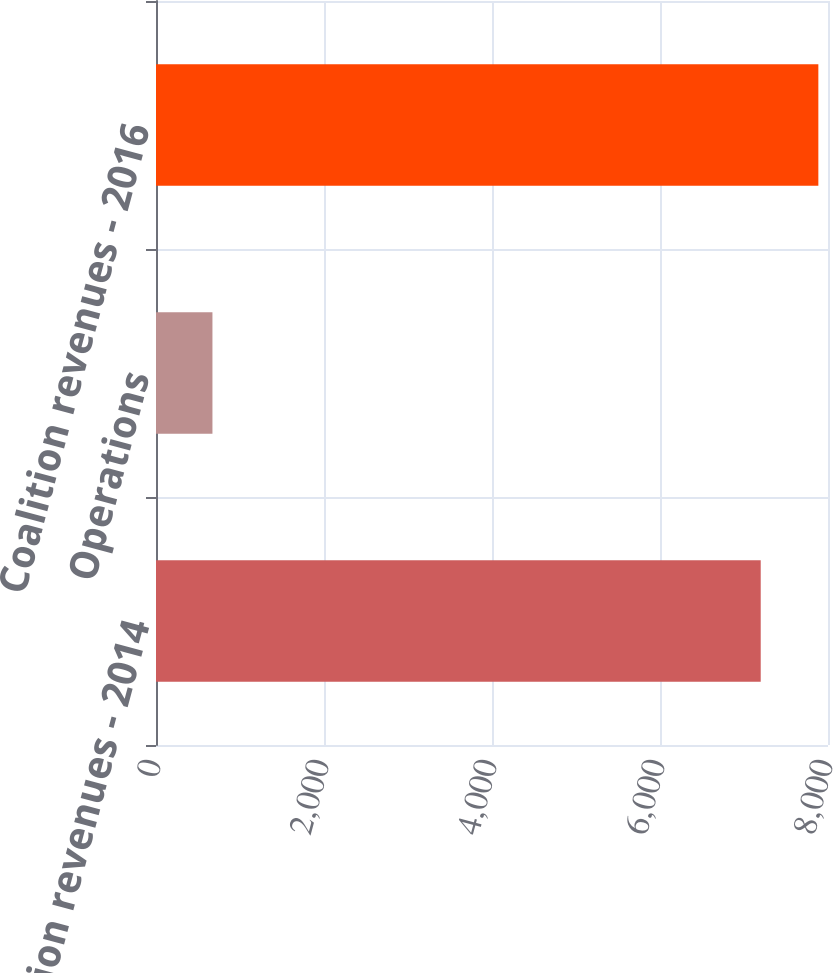<chart> <loc_0><loc_0><loc_500><loc_500><bar_chart><fcel>Coalition revenues - 2014<fcel>Operations<fcel>Coalition revenues - 2016<nl><fcel>7199<fcel>672<fcel>7885.11<nl></chart> 